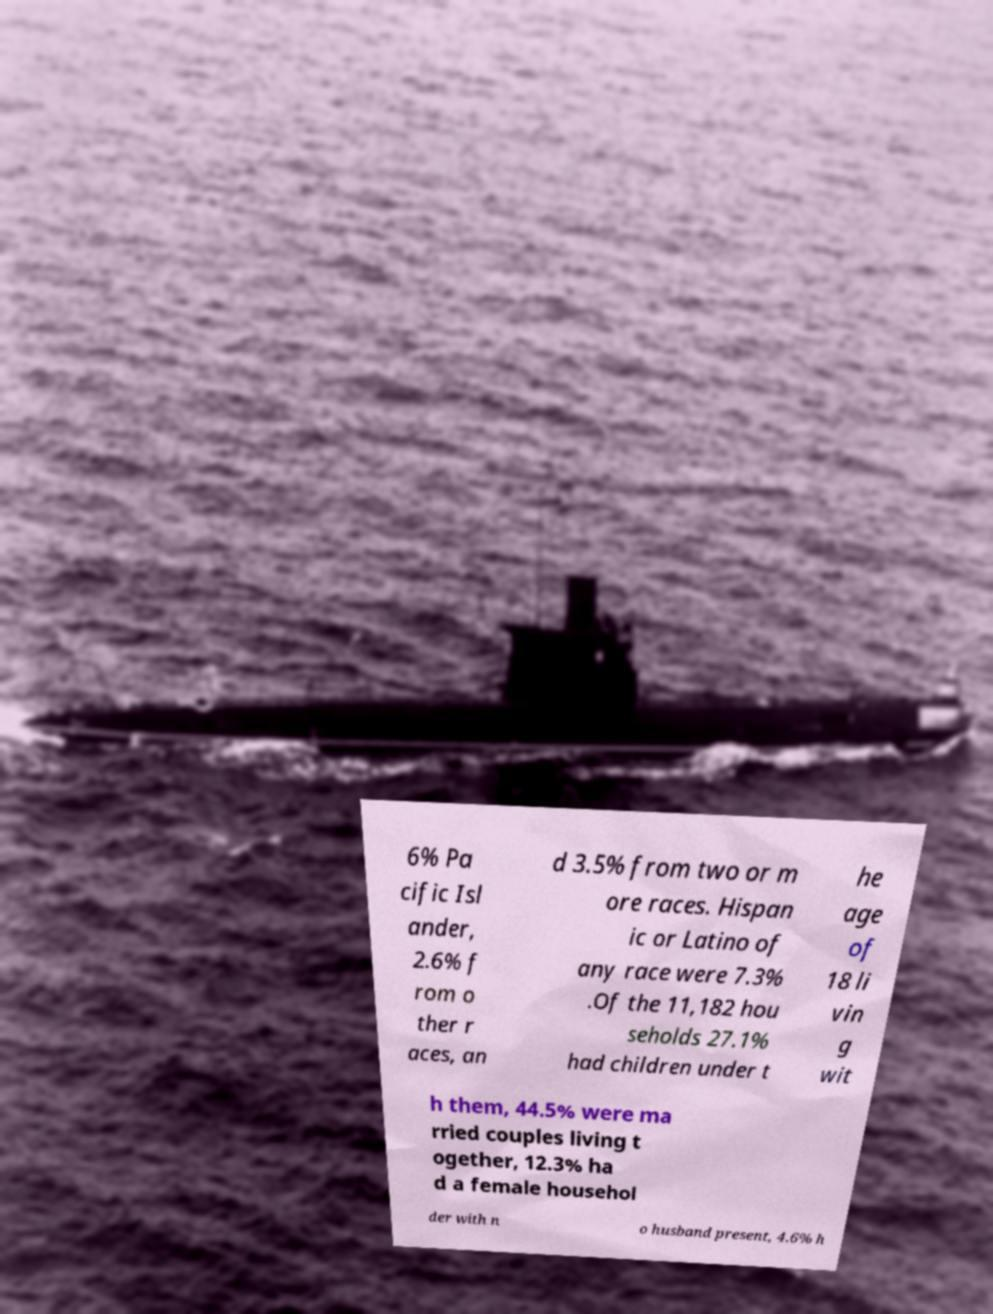For documentation purposes, I need the text within this image transcribed. Could you provide that? 6% Pa cific Isl ander, 2.6% f rom o ther r aces, an d 3.5% from two or m ore races. Hispan ic or Latino of any race were 7.3% .Of the 11,182 hou seholds 27.1% had children under t he age of 18 li vin g wit h them, 44.5% were ma rried couples living t ogether, 12.3% ha d a female househol der with n o husband present, 4.6% h 